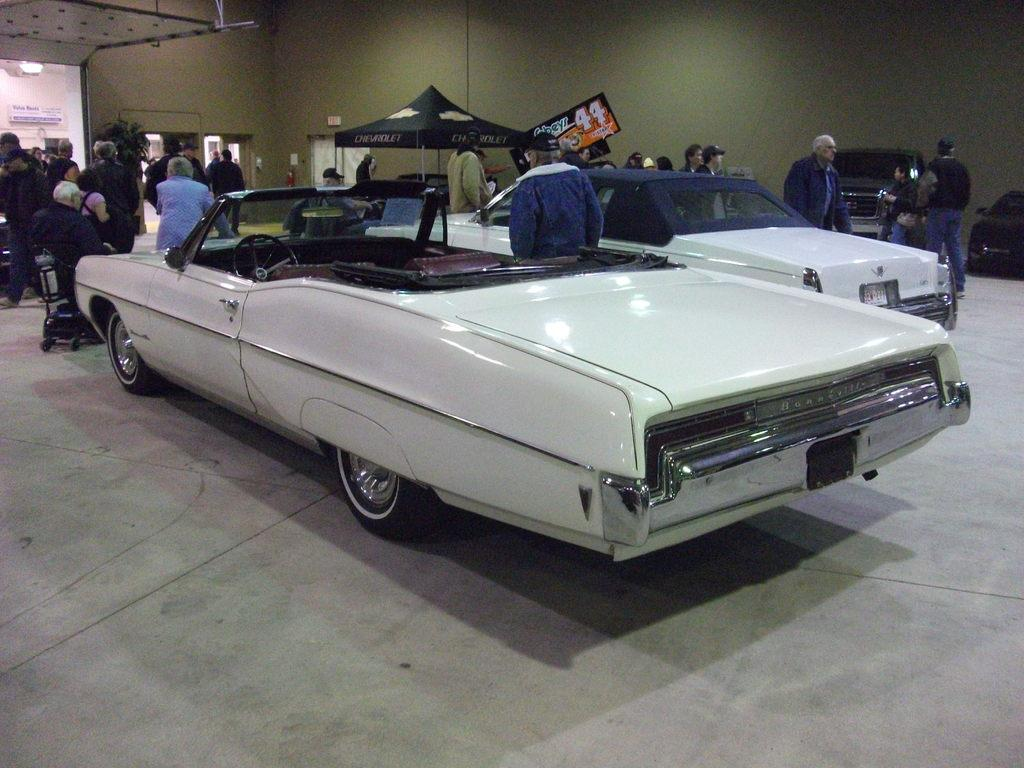What can be seen in the foreground of the image? In the foreground of the image, there are people, vehicles, and a tent. What is located in the background of the image? In the background of the image, there are potted plants and a wall with frames. What type of surface is visible at the bottom of the image? A floor is visible at the bottom of the image. What type of toothpaste is being used by the farmer in the image? There is no farmer or toothpaste present in the image. What force is being applied to the vehicles in the image? There is no force being applied to the vehicles in the image; they are stationary. 